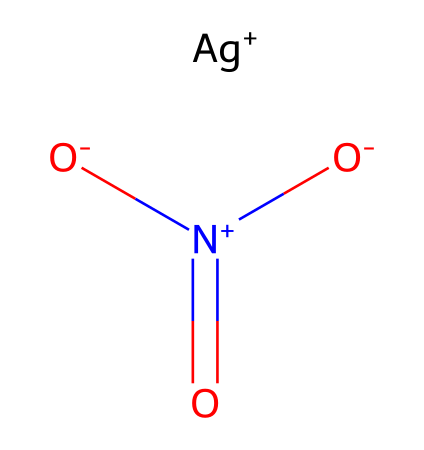What is the metal ion present in this compound? By examining the structure represented in the SMILES notation, it can be noted that [Ag+] indicates the presence of silver, which is the metal ion in this chemical.
Answer: silver How many oxygen atoms are present in silver nitrate? The SMILES notation indicates three oxygen atoms represented by the three 'O' letters in the chemical structure, confirming that there are three oxygen atoms in silver nitrate.
Answer: three What charge does the nitrate ion carry in this compound? The SMILES representation shows [N+](=O)([O-])[O-], which indicates that nitrogen has a positive charge (+) while two of the oxygen atoms are negatively charged (-). The overall charge of the nitrate ion is negative due to the presence of two negatively charged oxygen atoms.
Answer: negative What type of chemical compound is silver nitrate categorized as? Silver nitrate comprises silver and nitrate ions in a coordination compound framework where silver acts as the central metal ion coordinated with the nitrate ions. Therefore, it is classified as a coordination compound.
Answer: coordination compound How many bonds are formed between the silver ion and the nitrate ion? The structure reveals that the silver ion forms an ionic bond with the nitrate ion, indicating that one bond is formed between them.
Answer: one What is the oxidation state of the silver ion in this compound? In this compound, the silver ion exhibits a +1 oxidation state, as denoted by [Ag+], which clearly indicates its positive charge.
Answer: +1 